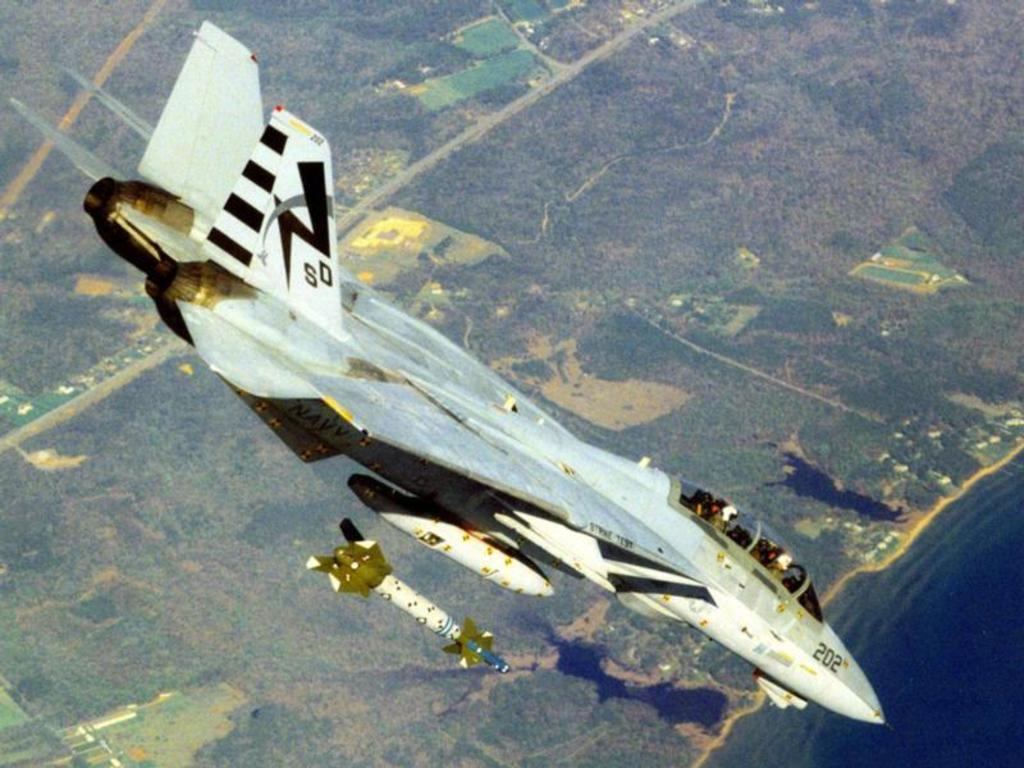<image>
Describe the image concisely. An F14 is shown launching a missile, the plane is number 202. 